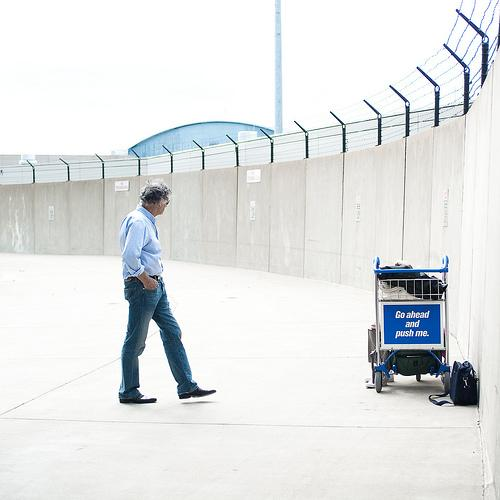Analyze the environment's weather conditions in the image. The environment has a white overcast sky, suggesting cloudy or gloomy weather conditions. What type of object is present next to the cart, and what are its main characteristics? A case, possibly a blue briefcase, is present next to the cart. It is on the ground and has dimensions of Width: 55 and Height: 55. Examine the image and deduce reasoning behind the presence of the cart, wall, and the man. The presence of the cart, wall, and man might suggest a situation where the man is moving or transporting belongings in a secured area, perhaps near an industrial site or a border. Identify any potential anomalies or unusual objects in the image. The large cement wall with barb wire on top and the secured area might be considered an anomaly or unusual object in the image. Identify and describe the type of wall visible in the image. A large cement wall with bent rods and barb wire on top is visible in the image, signifying a secured or restricted area. Can you provide a brief description of the man's attire and his position in the image? The man is wearing blue jeans, a light blue dress shirt with rolled up sleeves, and a brown leather belt. He has grey hair and is walking along the ground with his hands in his pockets. What are the main features of the cart in the image? The cart is metal and blue, with a blue handle for pushing, a wheel on the back, and a sign encouraging its usage. What does the sign on the cart encourage people to do? The sign on the cart encourages its usage and says "push me." Based on the image, segment and describe the different objects present. Segments include a man walking, wearing blue jeans and a blue shirt, a blue metal cart with a handle and a sign, a case on the ground, a large cement wall with barb wire, and an overcast sky. In the context of the image, analyze the overall sentiment. The overall sentiment of the image is somewhat melancholic due to the overcast sky, the man walking with hands in his pockets, and the secured wall. 